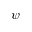<formula> <loc_0><loc_0><loc_500><loc_500>\psi</formula> 